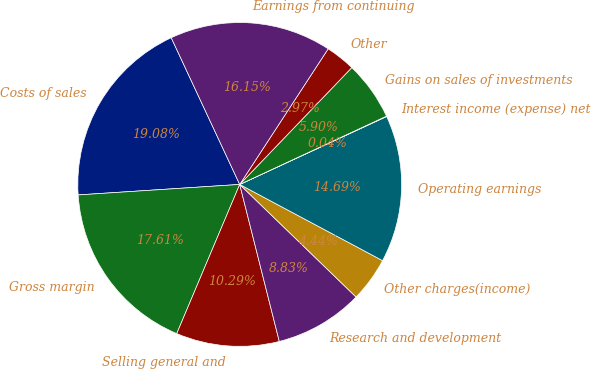<chart> <loc_0><loc_0><loc_500><loc_500><pie_chart><fcel>Costs of sales<fcel>Gross margin<fcel>Selling general and<fcel>Research and development<fcel>Other charges(income)<fcel>Operating earnings<fcel>Interest income (expense) net<fcel>Gains on sales of investments<fcel>Other<fcel>Earnings from continuing<nl><fcel>19.08%<fcel>17.61%<fcel>10.29%<fcel>8.83%<fcel>4.44%<fcel>14.69%<fcel>0.04%<fcel>5.9%<fcel>2.97%<fcel>16.15%<nl></chart> 